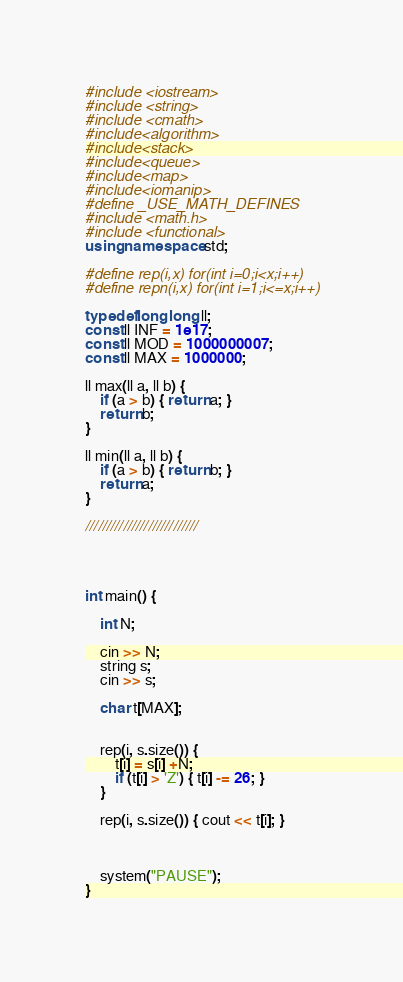<code> <loc_0><loc_0><loc_500><loc_500><_C++_>#include <iostream>
#include <string>
#include <cmath>
#include<algorithm>
#include<stack>
#include<queue>
#include<map>
#include<iomanip>
#define _USE_MATH_DEFINES
#include <math.h>
#include <functional>
using namespace std;

#define rep(i,x) for(int i=0;i<x;i++)
#define repn(i,x) for(int i=1;i<=x;i++)

typedef long long ll;
const ll INF = 1e17;
const ll MOD = 1000000007;
const ll MAX = 1000000;

ll max(ll a, ll b) {
	if (a > b) { return a; }
	return b;
}

ll min(ll a, ll b) {
	if (a > b) { return b; }
	return a;
}

///////////////////////////




int main() {

	int N;

	cin >> N;
	string s;
	cin >> s;

	char t[MAX];

	
	rep(i, s.size()) {
		t[i] = s[i] +N;
		if (t[i] > 'Z') { t[i] -= 26; }
	}

	rep(i, s.size()) { cout << t[i]; }

		

	system("PAUSE");
}
</code> 